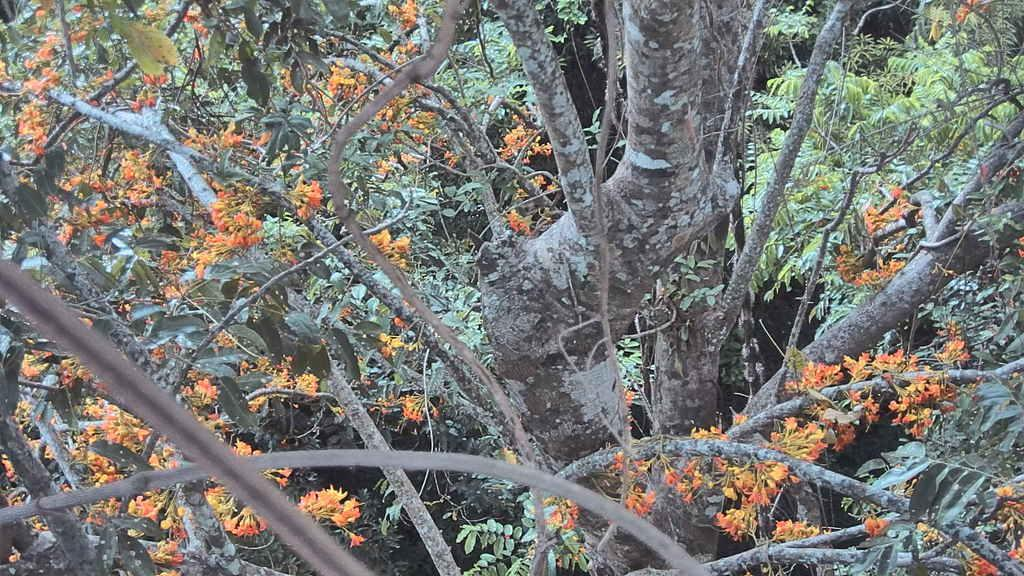What type of vegetation can be seen in the image? There are trees and flowers in the image. Can you describe the colors of the flowers? The colors of the flowers cannot be determined from the provided facts. What is the primary setting of the image? The primary setting of the image is a natural environment with trees and flowers. What type of sound can be heard coming from the flowers in the image? There is no sound coming from the flowers in the image, as flowers do not produce sound. 